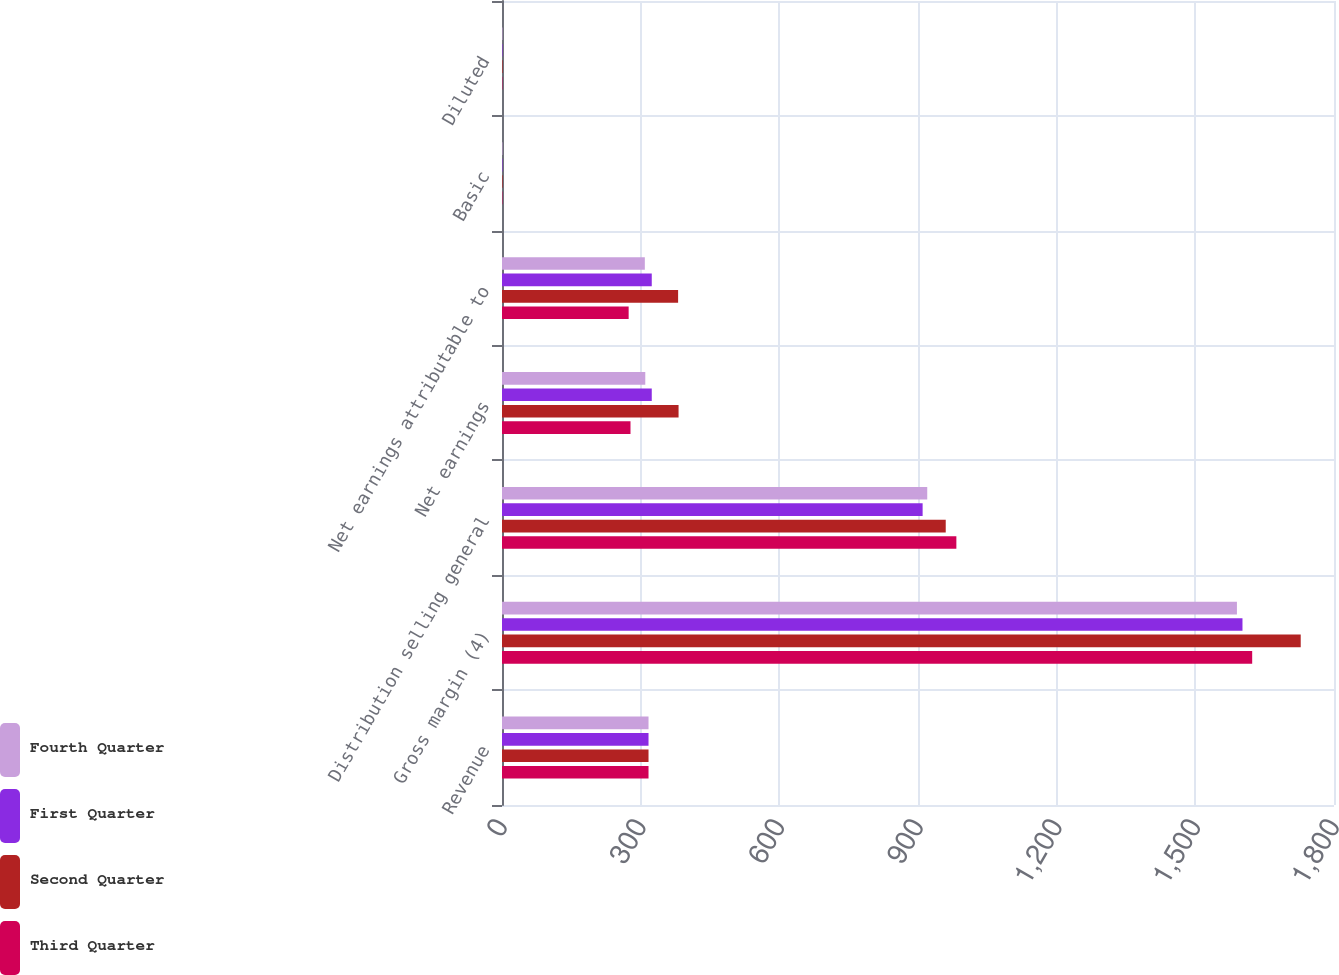Convert chart. <chart><loc_0><loc_0><loc_500><loc_500><stacked_bar_chart><ecel><fcel>Revenue<fcel>Gross margin (4)<fcel>Distribution selling general<fcel>Net earnings<fcel>Net earnings attributable to<fcel>Basic<fcel>Diluted<nl><fcel>Fourth Quarter<fcel>317<fcel>1590<fcel>920<fcel>310<fcel>309<fcel>0.97<fcel>0.96<nl><fcel>First Quarter<fcel>317<fcel>1602<fcel>910<fcel>324<fcel>324<fcel>1.02<fcel>1.02<nl><fcel>Second Quarter<fcel>317<fcel>1728<fcel>960<fcel>382<fcel>381<fcel>1.21<fcel>1.2<nl><fcel>Third Quarter<fcel>317<fcel>1623<fcel>983<fcel>278<fcel>274<fcel>0.87<fcel>0.86<nl></chart> 